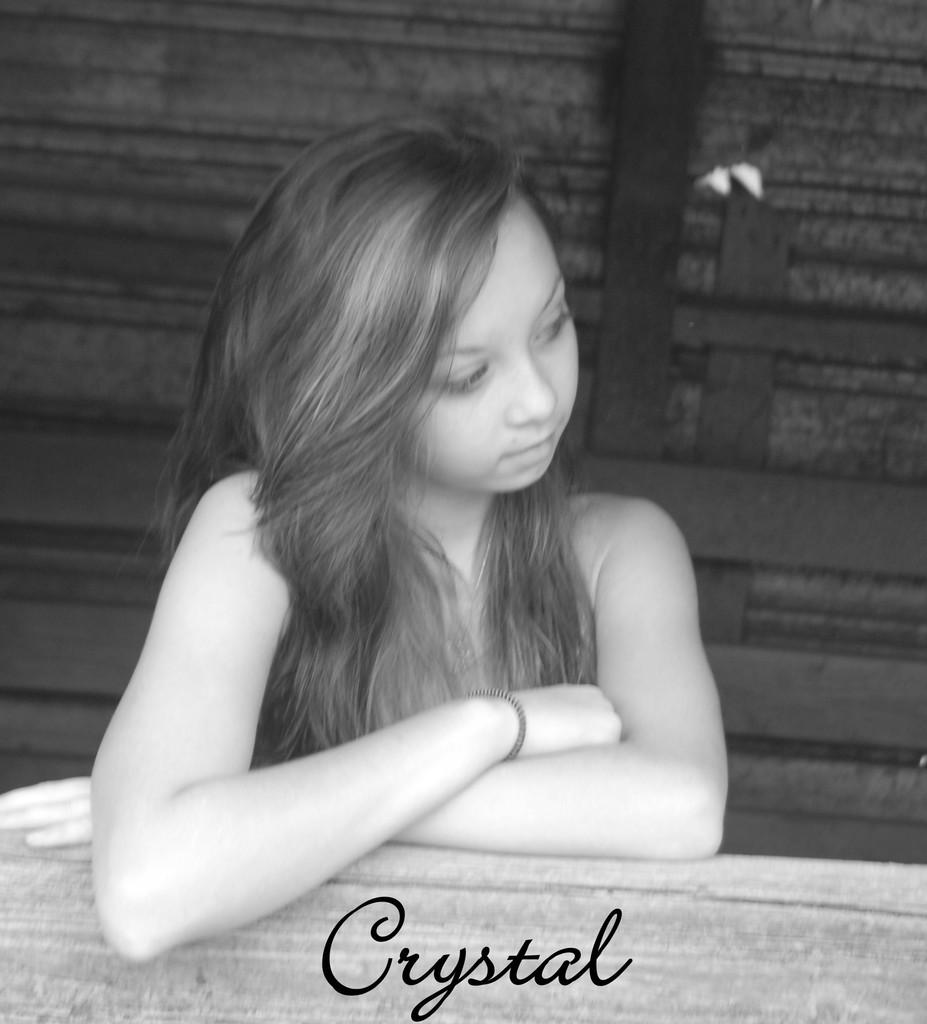Who or what is the main subject in the image? There is a person in the image. What is in front of the person? There is a table in front of the person. What type of objects can be seen in the background of the image? There are wooden objects in the background of the image. How is the image presented in terms of color? The image is in black and white. Can you tell me how the person is experiencing pleasure in the image? There is no indication of pleasure or any specific emotion in the image, as it is presented in black and white and does not show the person's facial expression. 